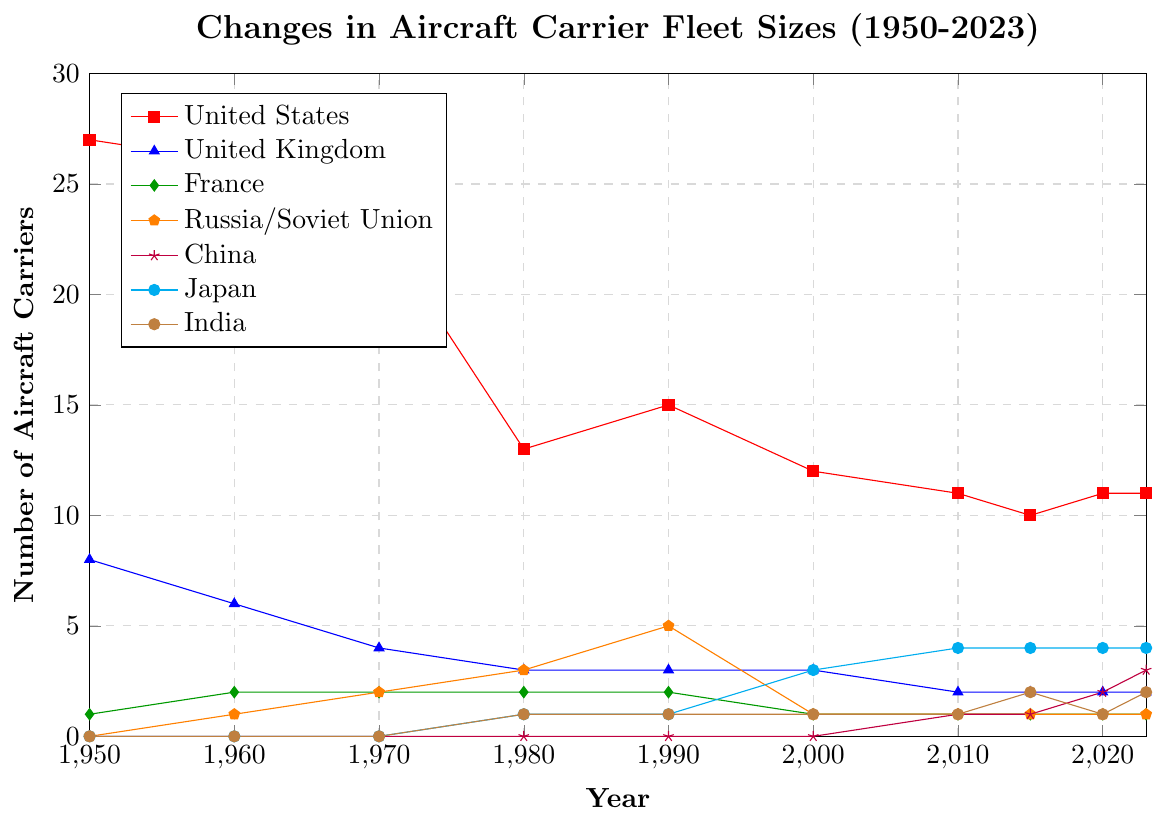Which nation had the highest number of aircraft carriers in 1950? From the figure, the highest line in 1950 corresponds to the United States, with 27 aircraft carriers.
Answer: United States How did the fleet size of the United Kingdom change from 1950 to 1980? The figure shows the fleet size of the United Kingdom was 8 in 1950 and decreased to 3 by 1980.
Answer: It decreased by 5 Between 2010 and 2023, which country saw the greatest increase in aircraft carrier numbers? By comparing the fleet sizes in 2010 and 2023, China increased from 1 to 3, making a net increase of 2, which is the greatest among all countries.
Answer: China Compare the fleet sizes of France and Russia/Soviet Union in the year 2000. Which country had more aircraft carriers? In the year 2000, the figure shows France had 1 aircraft carrier and Russia/Soviet Union had 1 aircraft carrier.
Answer: They had the same number What was the overall trend for the United States' fleet size from 1950 to 2023? The United States' fleet size decreased overall from 27 in 1950 to 11 in 2023, despite minor fluctuations during some years.
Answer: Decreasing Which country had no aircraft carriers from 1950 to 1970 but then started to have them? Observing the data, China had no aircraft carriers from 1950 to 1970 and started acquiring them from around 2010.
Answer: China In 2023, how many countries had exactly 2 aircraft carriers? By looking at the fleet sizes in 2023, the United Kingdom and India each had 2 aircraft carriers.
Answer: Two countries What was the difference in the number of aircraft carriers between Japan and China in 2023? In 2023, Japan had 4 aircraft carriers and China had 3, leading to a difference of 1.
Answer: 1 Which country had the most stable number of aircraft carriers in the period 1950 to 2023? France maintained relatively stable numbers, fluctuating between 1 and 2 aircraft carriers throughout the entire period.
Answer: France 